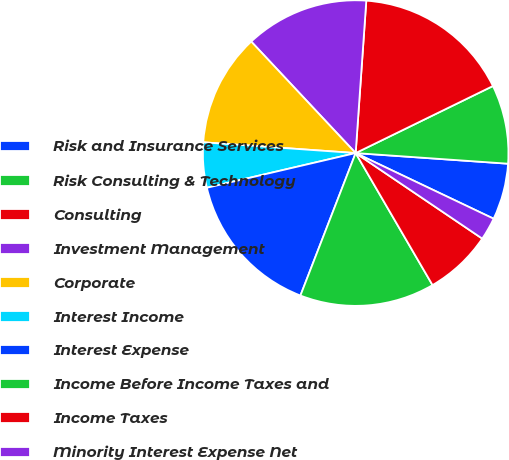<chart> <loc_0><loc_0><loc_500><loc_500><pie_chart><fcel>Risk and Insurance Services<fcel>Risk Consulting & Technology<fcel>Consulting<fcel>Investment Management<fcel>Corporate<fcel>Interest Income<fcel>Interest Expense<fcel>Income Before Income Taxes and<fcel>Income Taxes<fcel>Minority Interest Expense Net<nl><fcel>5.96%<fcel>8.34%<fcel>16.66%<fcel>13.09%<fcel>11.9%<fcel>4.77%<fcel>15.47%<fcel>14.28%<fcel>7.15%<fcel>2.39%<nl></chart> 